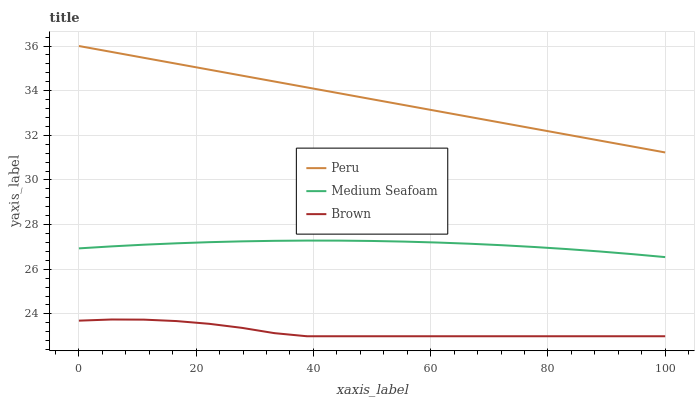Does Brown have the minimum area under the curve?
Answer yes or no. Yes. Does Peru have the maximum area under the curve?
Answer yes or no. Yes. Does Medium Seafoam have the minimum area under the curve?
Answer yes or no. No. Does Medium Seafoam have the maximum area under the curve?
Answer yes or no. No. Is Peru the smoothest?
Answer yes or no. Yes. Is Brown the roughest?
Answer yes or no. Yes. Is Medium Seafoam the smoothest?
Answer yes or no. No. Is Medium Seafoam the roughest?
Answer yes or no. No. Does Brown have the lowest value?
Answer yes or no. Yes. Does Medium Seafoam have the lowest value?
Answer yes or no. No. Does Peru have the highest value?
Answer yes or no. Yes. Does Medium Seafoam have the highest value?
Answer yes or no. No. Is Brown less than Peru?
Answer yes or no. Yes. Is Peru greater than Medium Seafoam?
Answer yes or no. Yes. Does Brown intersect Peru?
Answer yes or no. No. 